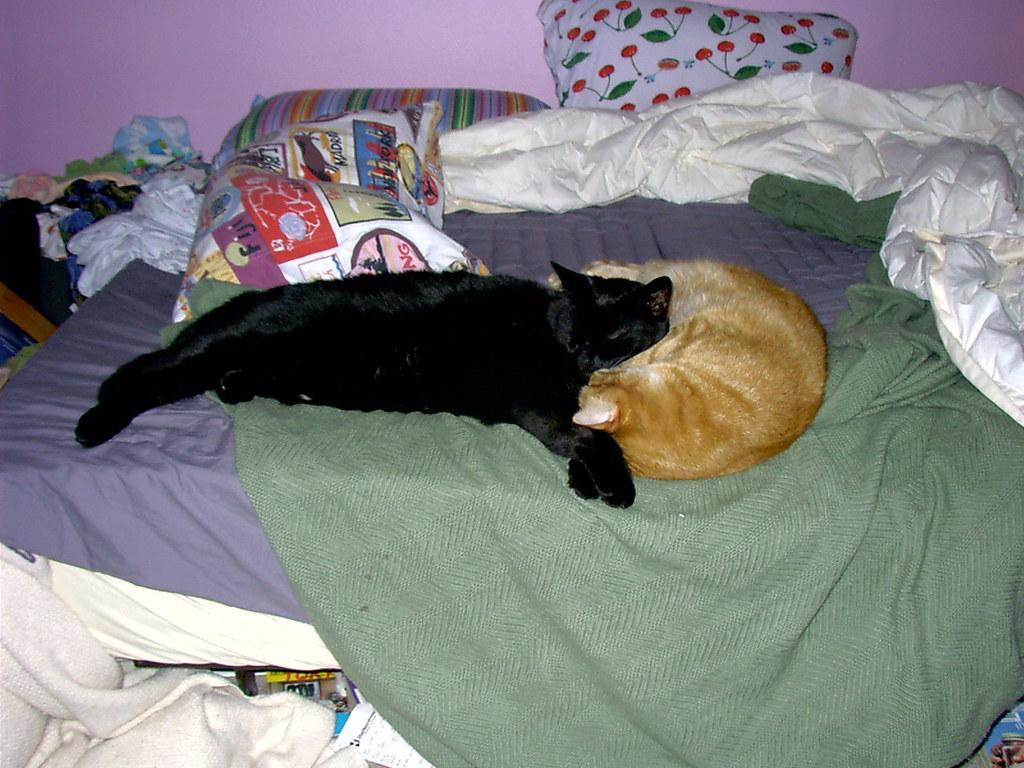How many cats are in the image? There are two cats in the image, one black and one brown. Where are the cats located in the image? The cats are lying on a bed. What is covering the bed in the image? The bed has bed sheets, blankets, and pillows. What other items are on the bed in the image? There are dresses and a towel on the bed. What color is the wall in the image? The wall is pink in color. What type of office furniture can be seen in the image? There is no office furniture present in the image; it features two cats lying on a bed with various items. How many cattle are visible in the image? There are no cattle present in the image; it features two cats lying on a bed with various items. 